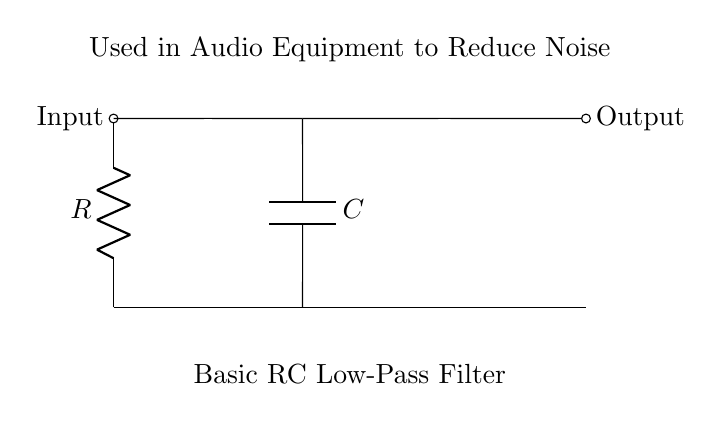What type of filter is represented in the circuit? The circuit shows a low-pass filter configuration, which allows low-frequency signals to pass while attenuating high-frequency signals.
Answer: Low-pass filter What components are present in this circuit? The circuit consists of a resistor and a capacitor that work together to form the filter.
Answer: Resistor and capacitor What is the primary purpose of this circuit? The circuit is designed to reduce noise in audio equipment, making it clearer by filtering out unwanted high-frequency sounds.
Answer: Reduce noise How many components are in the circuit? There are two main components: one resistor and one capacitor that comprise the basic RC filter.
Answer: Two What signal conditions can this circuit primarily handle? The circuit is primarily used to handle audio signals, particularly to filter out unwanted high frequencies.
Answer: Audio signals What happens to high-frequency signals in this circuit? High-frequency signals are attenuated or reduced, meaning they are less prominent in the output compared to low-frequency signals.
Answer: Attenuated 